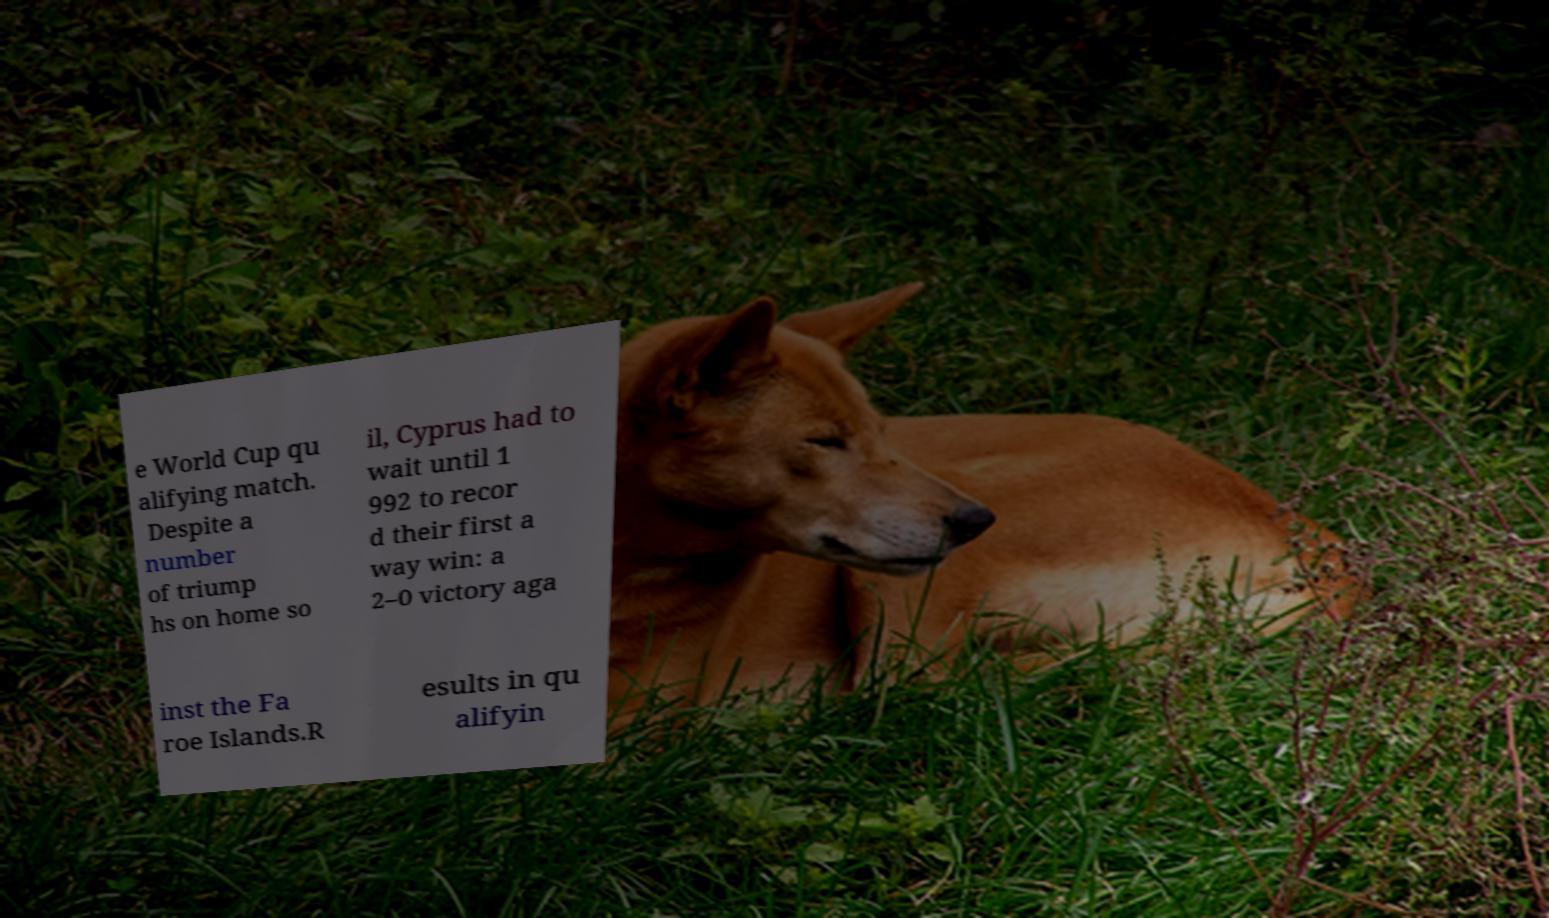Could you assist in decoding the text presented in this image and type it out clearly? e World Cup qu alifying match. Despite a number of triump hs on home so il, Cyprus had to wait until 1 992 to recor d their first a way win: a 2–0 victory aga inst the Fa roe Islands.R esults in qu alifyin 